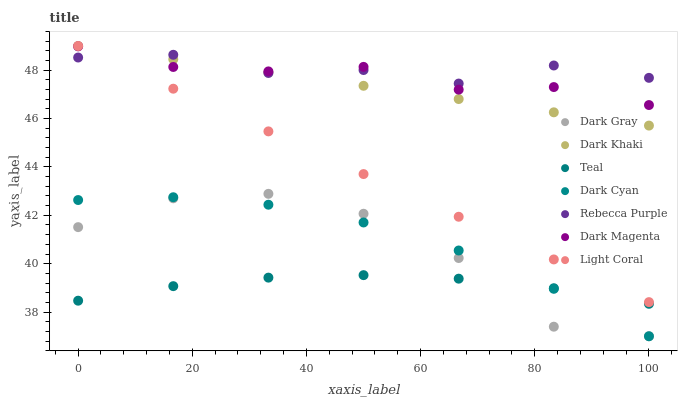Does Teal have the minimum area under the curve?
Answer yes or no. Yes. Does Rebecca Purple have the maximum area under the curve?
Answer yes or no. Yes. Does Dark Magenta have the minimum area under the curve?
Answer yes or no. No. Does Dark Magenta have the maximum area under the curve?
Answer yes or no. No. Is Dark Khaki the smoothest?
Answer yes or no. Yes. Is Dark Gray the roughest?
Answer yes or no. Yes. Is Dark Magenta the smoothest?
Answer yes or no. No. Is Dark Magenta the roughest?
Answer yes or no. No. Does Dark Gray have the lowest value?
Answer yes or no. Yes. Does Dark Magenta have the lowest value?
Answer yes or no. No. Does Light Coral have the highest value?
Answer yes or no. Yes. Does Dark Magenta have the highest value?
Answer yes or no. No. Is Dark Cyan less than Dark Magenta?
Answer yes or no. Yes. Is Dark Khaki greater than Dark Gray?
Answer yes or no. Yes. Does Dark Cyan intersect Dark Gray?
Answer yes or no. Yes. Is Dark Cyan less than Dark Gray?
Answer yes or no. No. Is Dark Cyan greater than Dark Gray?
Answer yes or no. No. Does Dark Cyan intersect Dark Magenta?
Answer yes or no. No. 